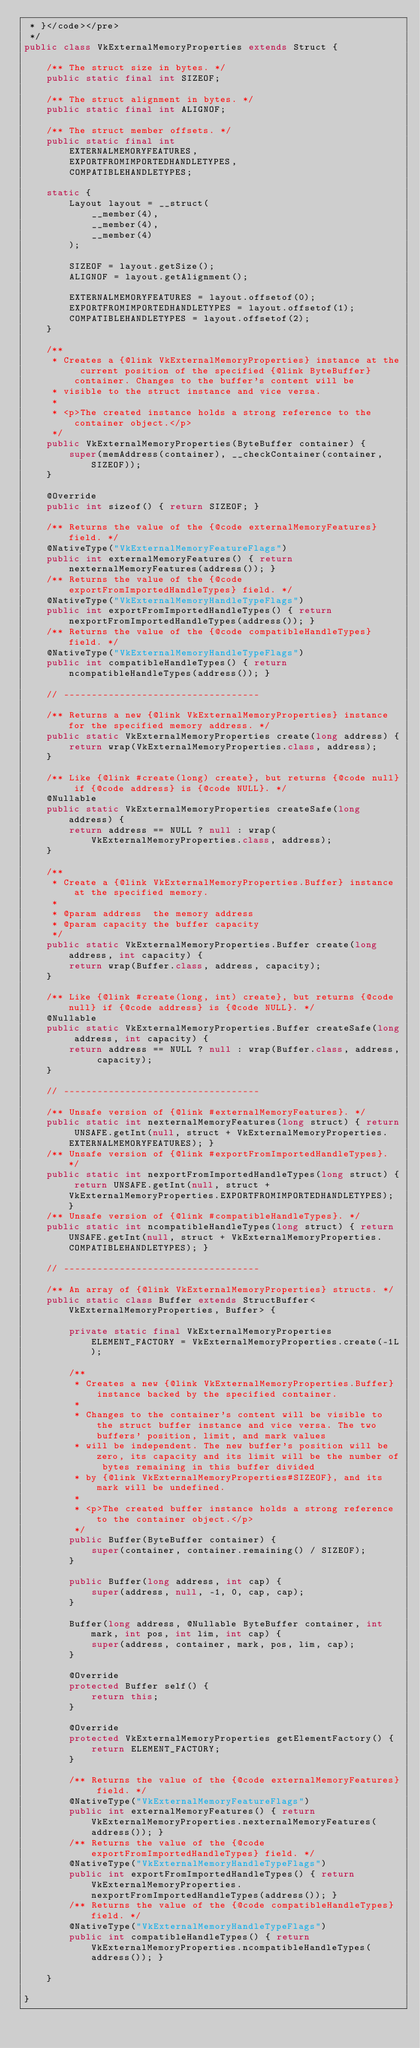Convert code to text. <code><loc_0><loc_0><loc_500><loc_500><_Java_> * }</code></pre>
 */
public class VkExternalMemoryProperties extends Struct {

    /** The struct size in bytes. */
    public static final int SIZEOF;

    /** The struct alignment in bytes. */
    public static final int ALIGNOF;

    /** The struct member offsets. */
    public static final int
        EXTERNALMEMORYFEATURES,
        EXPORTFROMIMPORTEDHANDLETYPES,
        COMPATIBLEHANDLETYPES;

    static {
        Layout layout = __struct(
            __member(4),
            __member(4),
            __member(4)
        );

        SIZEOF = layout.getSize();
        ALIGNOF = layout.getAlignment();

        EXTERNALMEMORYFEATURES = layout.offsetof(0);
        EXPORTFROMIMPORTEDHANDLETYPES = layout.offsetof(1);
        COMPATIBLEHANDLETYPES = layout.offsetof(2);
    }

    /**
     * Creates a {@link VkExternalMemoryProperties} instance at the current position of the specified {@link ByteBuffer} container. Changes to the buffer's content will be
     * visible to the struct instance and vice versa.
     *
     * <p>The created instance holds a strong reference to the container object.</p>
     */
    public VkExternalMemoryProperties(ByteBuffer container) {
        super(memAddress(container), __checkContainer(container, SIZEOF));
    }

    @Override
    public int sizeof() { return SIZEOF; }

    /** Returns the value of the {@code externalMemoryFeatures} field. */
    @NativeType("VkExternalMemoryFeatureFlags")
    public int externalMemoryFeatures() { return nexternalMemoryFeatures(address()); }
    /** Returns the value of the {@code exportFromImportedHandleTypes} field. */
    @NativeType("VkExternalMemoryHandleTypeFlags")
    public int exportFromImportedHandleTypes() { return nexportFromImportedHandleTypes(address()); }
    /** Returns the value of the {@code compatibleHandleTypes} field. */
    @NativeType("VkExternalMemoryHandleTypeFlags")
    public int compatibleHandleTypes() { return ncompatibleHandleTypes(address()); }

    // -----------------------------------

    /** Returns a new {@link VkExternalMemoryProperties} instance for the specified memory address. */
    public static VkExternalMemoryProperties create(long address) {
        return wrap(VkExternalMemoryProperties.class, address);
    }

    /** Like {@link #create(long) create}, but returns {@code null} if {@code address} is {@code NULL}. */
    @Nullable
    public static VkExternalMemoryProperties createSafe(long address) {
        return address == NULL ? null : wrap(VkExternalMemoryProperties.class, address);
    }

    /**
     * Create a {@link VkExternalMemoryProperties.Buffer} instance at the specified memory.
     *
     * @param address  the memory address
     * @param capacity the buffer capacity
     */
    public static VkExternalMemoryProperties.Buffer create(long address, int capacity) {
        return wrap(Buffer.class, address, capacity);
    }

    /** Like {@link #create(long, int) create}, but returns {@code null} if {@code address} is {@code NULL}. */
    @Nullable
    public static VkExternalMemoryProperties.Buffer createSafe(long address, int capacity) {
        return address == NULL ? null : wrap(Buffer.class, address, capacity);
    }

    // -----------------------------------

    /** Unsafe version of {@link #externalMemoryFeatures}. */
    public static int nexternalMemoryFeatures(long struct) { return UNSAFE.getInt(null, struct + VkExternalMemoryProperties.EXTERNALMEMORYFEATURES); }
    /** Unsafe version of {@link #exportFromImportedHandleTypes}. */
    public static int nexportFromImportedHandleTypes(long struct) { return UNSAFE.getInt(null, struct + VkExternalMemoryProperties.EXPORTFROMIMPORTEDHANDLETYPES); }
    /** Unsafe version of {@link #compatibleHandleTypes}. */
    public static int ncompatibleHandleTypes(long struct) { return UNSAFE.getInt(null, struct + VkExternalMemoryProperties.COMPATIBLEHANDLETYPES); }

    // -----------------------------------

    /** An array of {@link VkExternalMemoryProperties} structs. */
    public static class Buffer extends StructBuffer<VkExternalMemoryProperties, Buffer> {

        private static final VkExternalMemoryProperties ELEMENT_FACTORY = VkExternalMemoryProperties.create(-1L);

        /**
         * Creates a new {@link VkExternalMemoryProperties.Buffer} instance backed by the specified container.
         *
         * Changes to the container's content will be visible to the struct buffer instance and vice versa. The two buffers' position, limit, and mark values
         * will be independent. The new buffer's position will be zero, its capacity and its limit will be the number of bytes remaining in this buffer divided
         * by {@link VkExternalMemoryProperties#SIZEOF}, and its mark will be undefined.
         *
         * <p>The created buffer instance holds a strong reference to the container object.</p>
         */
        public Buffer(ByteBuffer container) {
            super(container, container.remaining() / SIZEOF);
        }

        public Buffer(long address, int cap) {
            super(address, null, -1, 0, cap, cap);
        }

        Buffer(long address, @Nullable ByteBuffer container, int mark, int pos, int lim, int cap) {
            super(address, container, mark, pos, lim, cap);
        }

        @Override
        protected Buffer self() {
            return this;
        }

        @Override
        protected VkExternalMemoryProperties getElementFactory() {
            return ELEMENT_FACTORY;
        }

        /** Returns the value of the {@code externalMemoryFeatures} field. */
        @NativeType("VkExternalMemoryFeatureFlags")
        public int externalMemoryFeatures() { return VkExternalMemoryProperties.nexternalMemoryFeatures(address()); }
        /** Returns the value of the {@code exportFromImportedHandleTypes} field. */
        @NativeType("VkExternalMemoryHandleTypeFlags")
        public int exportFromImportedHandleTypes() { return VkExternalMemoryProperties.nexportFromImportedHandleTypes(address()); }
        /** Returns the value of the {@code compatibleHandleTypes} field. */
        @NativeType("VkExternalMemoryHandleTypeFlags")
        public int compatibleHandleTypes() { return VkExternalMemoryProperties.ncompatibleHandleTypes(address()); }

    }

}</code> 